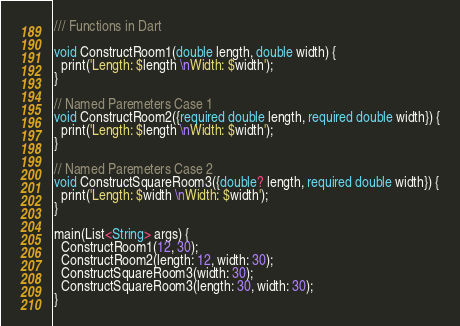Convert code to text. <code><loc_0><loc_0><loc_500><loc_500><_Dart_>/// Functions in Dart

void ConstructRoom1(double length, double width) {
  print('Length: $length \nWidth: $width');
}

// Named Paremeters Case 1
void ConstructRoom2({required double length, required double width}) {
  print('Length: $length \nWidth: $width');
}

// Named Paremeters Case 2
void ConstructSquareRoom3({double? length, required double width}) {
  print('Length: $width \nWidth: $width');
}

main(List<String> args) {
  ConstructRoom1(12, 30);
  ConstructRoom2(length: 12, width: 30);
  ConstructSquareRoom3(width: 30);
  ConstructSquareRoom3(length: 30, width: 30);
}
</code> 